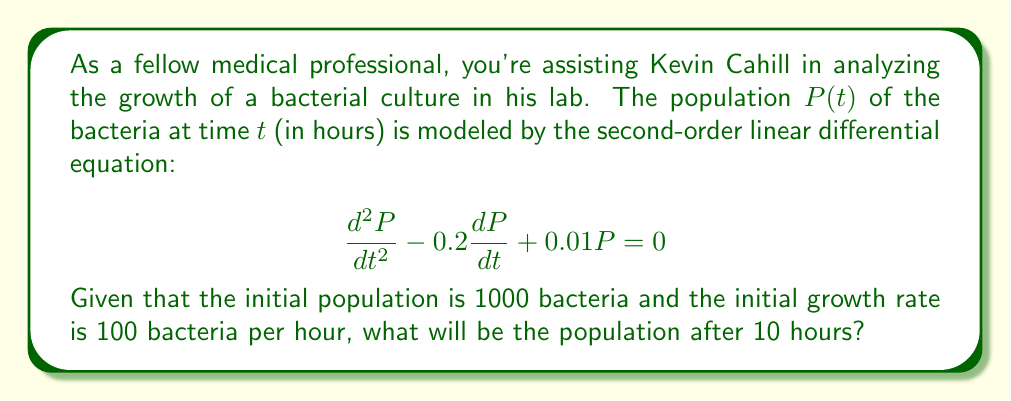Provide a solution to this math problem. To solve this problem, we need to follow these steps:

1) The general solution for this second-order linear differential equation is:

   $$P(t) = c_1e^{r_1t} + c_2e^{r_2t}$$

   where $r_1$ and $r_2$ are the roots of the characteristic equation.

2) The characteristic equation is:

   $$r^2 - 0.2r + 0.01 = 0$$

3) Solving this quadratic equation:

   $$r = \frac{0.2 \pm \sqrt{0.04 - 0.04}}{2} = 0.1$$

4) Since we have a repeated root, the general solution becomes:

   $$P(t) = (c_1 + c_2t)e^{0.1t}$$

5) Now we use the initial conditions to find $c_1$ and $c_2$:

   $P(0) = 1000$, so $c_1 = 1000$

   $\frac{dP}{dt}(0) = 100$, so $0.1c_1 + c_2 = 100$

6) Substituting $c_1 = 1000$ into the second equation:

   $100 + c_2 = 100$, so $c_2 = 0$

7) Therefore, our specific solution is:

   $$P(t) = 1000e^{0.1t}$$

8) To find the population after 10 hours, we calculate $P(10)$:

   $$P(10) = 1000e^{0.1(10)} = 1000e^1 \approx 2718.28$$
Answer: The population after 10 hours will be approximately 2718 bacteria. 